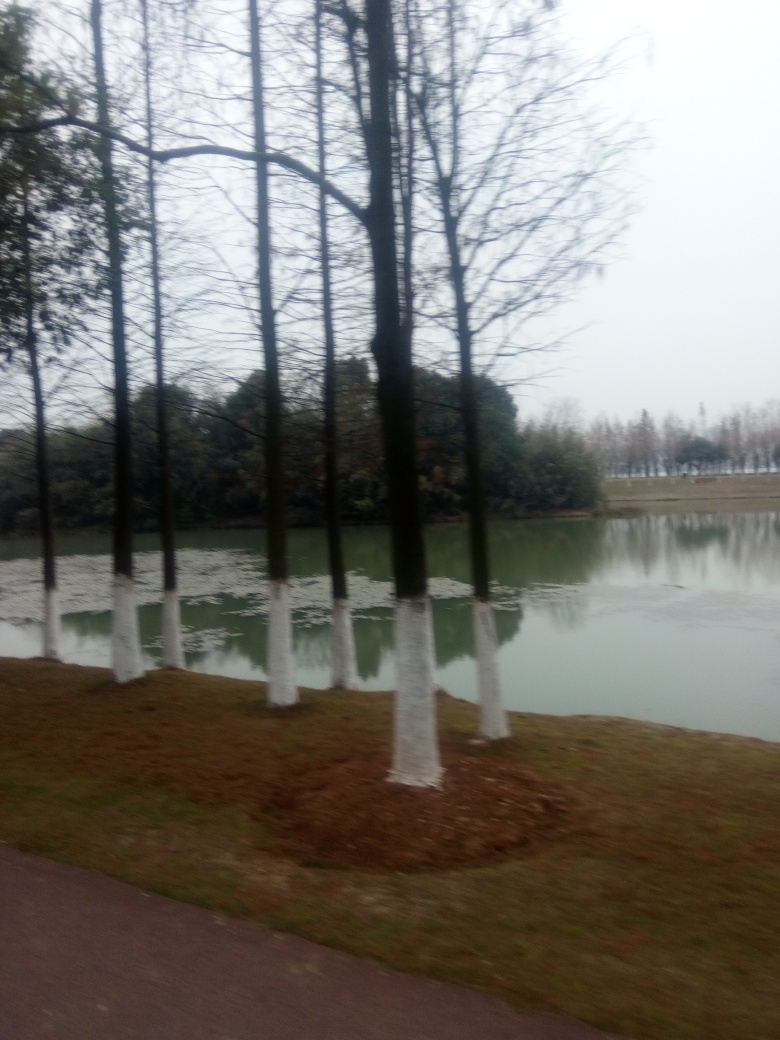Are there any quality issues with this image? Yes, the image appears to be blurry which affects the sharpness of the details. There is noticeable camera shake or motion blur, possibly due to a low shutter speed while the camera was in motion. This reduces the overall clarity of the scene, particularly the trees and the landscape in the background. 